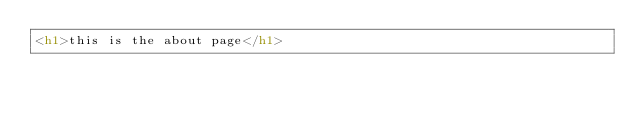<code> <loc_0><loc_0><loc_500><loc_500><_HTML_><h1>this is the about page</h1></code> 